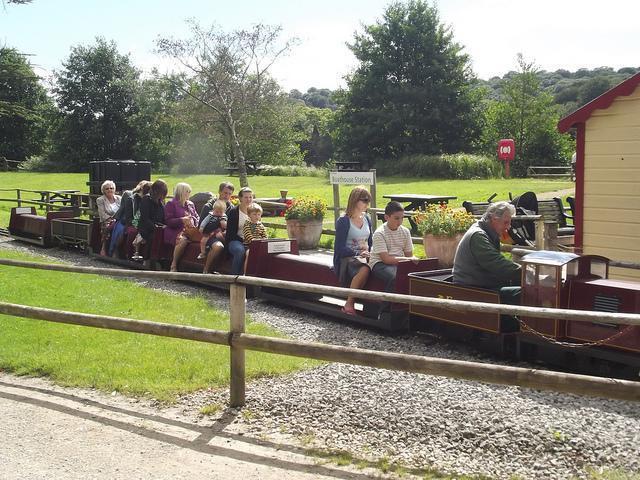What type people ride on this train?
Choose the correct response and explain in the format: 'Answer: answer
Rationale: rationale.'
Options: Elderly only, salesmen, mall workers, tourists. Answer: tourists.
Rationale: People come from other places to ride the train. 